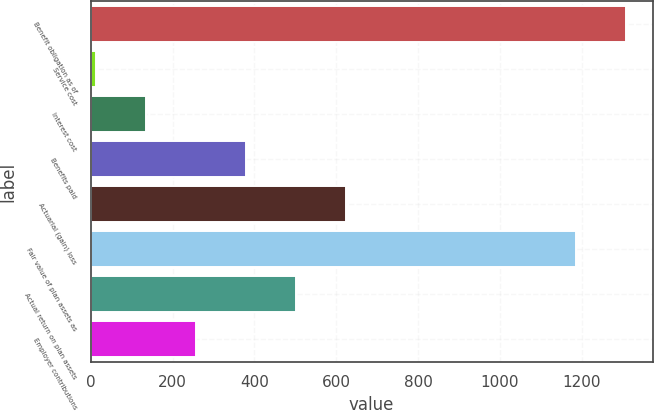Convert chart. <chart><loc_0><loc_0><loc_500><loc_500><bar_chart><fcel>Benefit obligation as of<fcel>Service cost<fcel>Interest cost<fcel>Benefits paid<fcel>Actuarial (gain) loss<fcel>Fair value of plan assets as<fcel>Actual return on plan assets<fcel>Employer contributions<nl><fcel>1307.3<fcel>14<fcel>136.1<fcel>380.3<fcel>624.5<fcel>1185.2<fcel>502.4<fcel>258.2<nl></chart> 